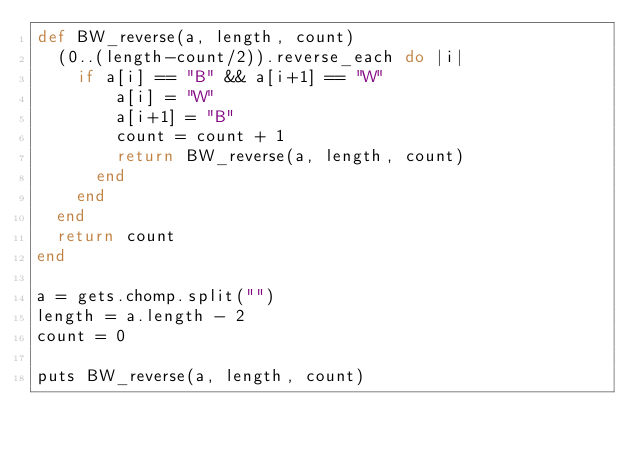<code> <loc_0><loc_0><loc_500><loc_500><_Ruby_>def BW_reverse(a, length, count)
  (0..(length-count/2)).reverse_each do |i|
    if a[i] == "B" && a[i+1] == "W"
        a[i] = "W"
        a[i+1] = "B"
        count = count + 1
        return BW_reverse(a, length, count)
      end
    end
  end
  return count
end

a = gets.chomp.split("")
length = a.length - 2
count = 0

puts BW_reverse(a, length, count)
</code> 